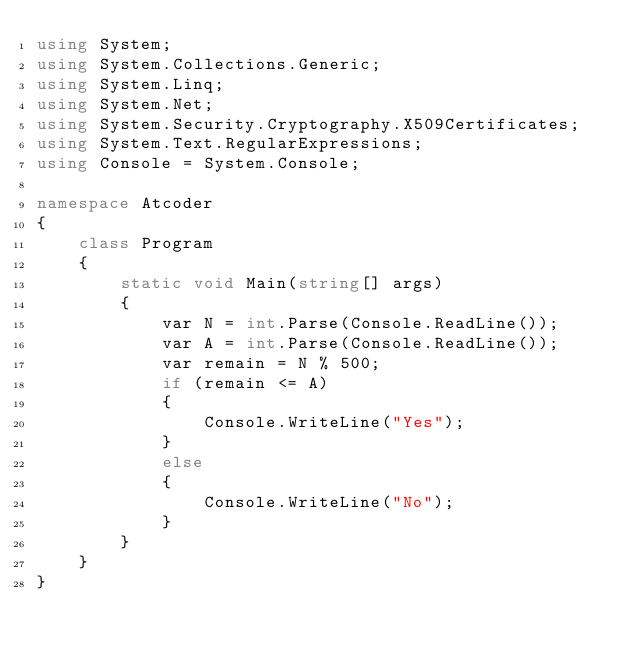Convert code to text. <code><loc_0><loc_0><loc_500><loc_500><_C#_>using System;
using System.Collections.Generic;
using System.Linq;
using System.Net;
using System.Security.Cryptography.X509Certificates;
using System.Text.RegularExpressions;
using Console = System.Console;

namespace Atcoder
{
    class Program
    {
        static void Main(string[] args)
        {
            var N = int.Parse(Console.ReadLine());
            var A = int.Parse(Console.ReadLine());
            var remain = N % 500;
            if (remain <= A)
            {
                Console.WriteLine("Yes");
            }
            else
            {
                Console.WriteLine("No");
            }
        }
    }
}</code> 